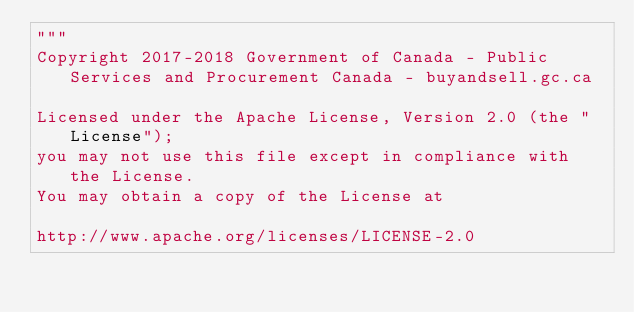<code> <loc_0><loc_0><loc_500><loc_500><_Python_>"""
Copyright 2017-2018 Government of Canada - Public Services and Procurement Canada - buyandsell.gc.ca

Licensed under the Apache License, Version 2.0 (the "License");
you may not use this file except in compliance with the License.
You may obtain a copy of the License at

http://www.apache.org/licenses/LICENSE-2.0
</code> 